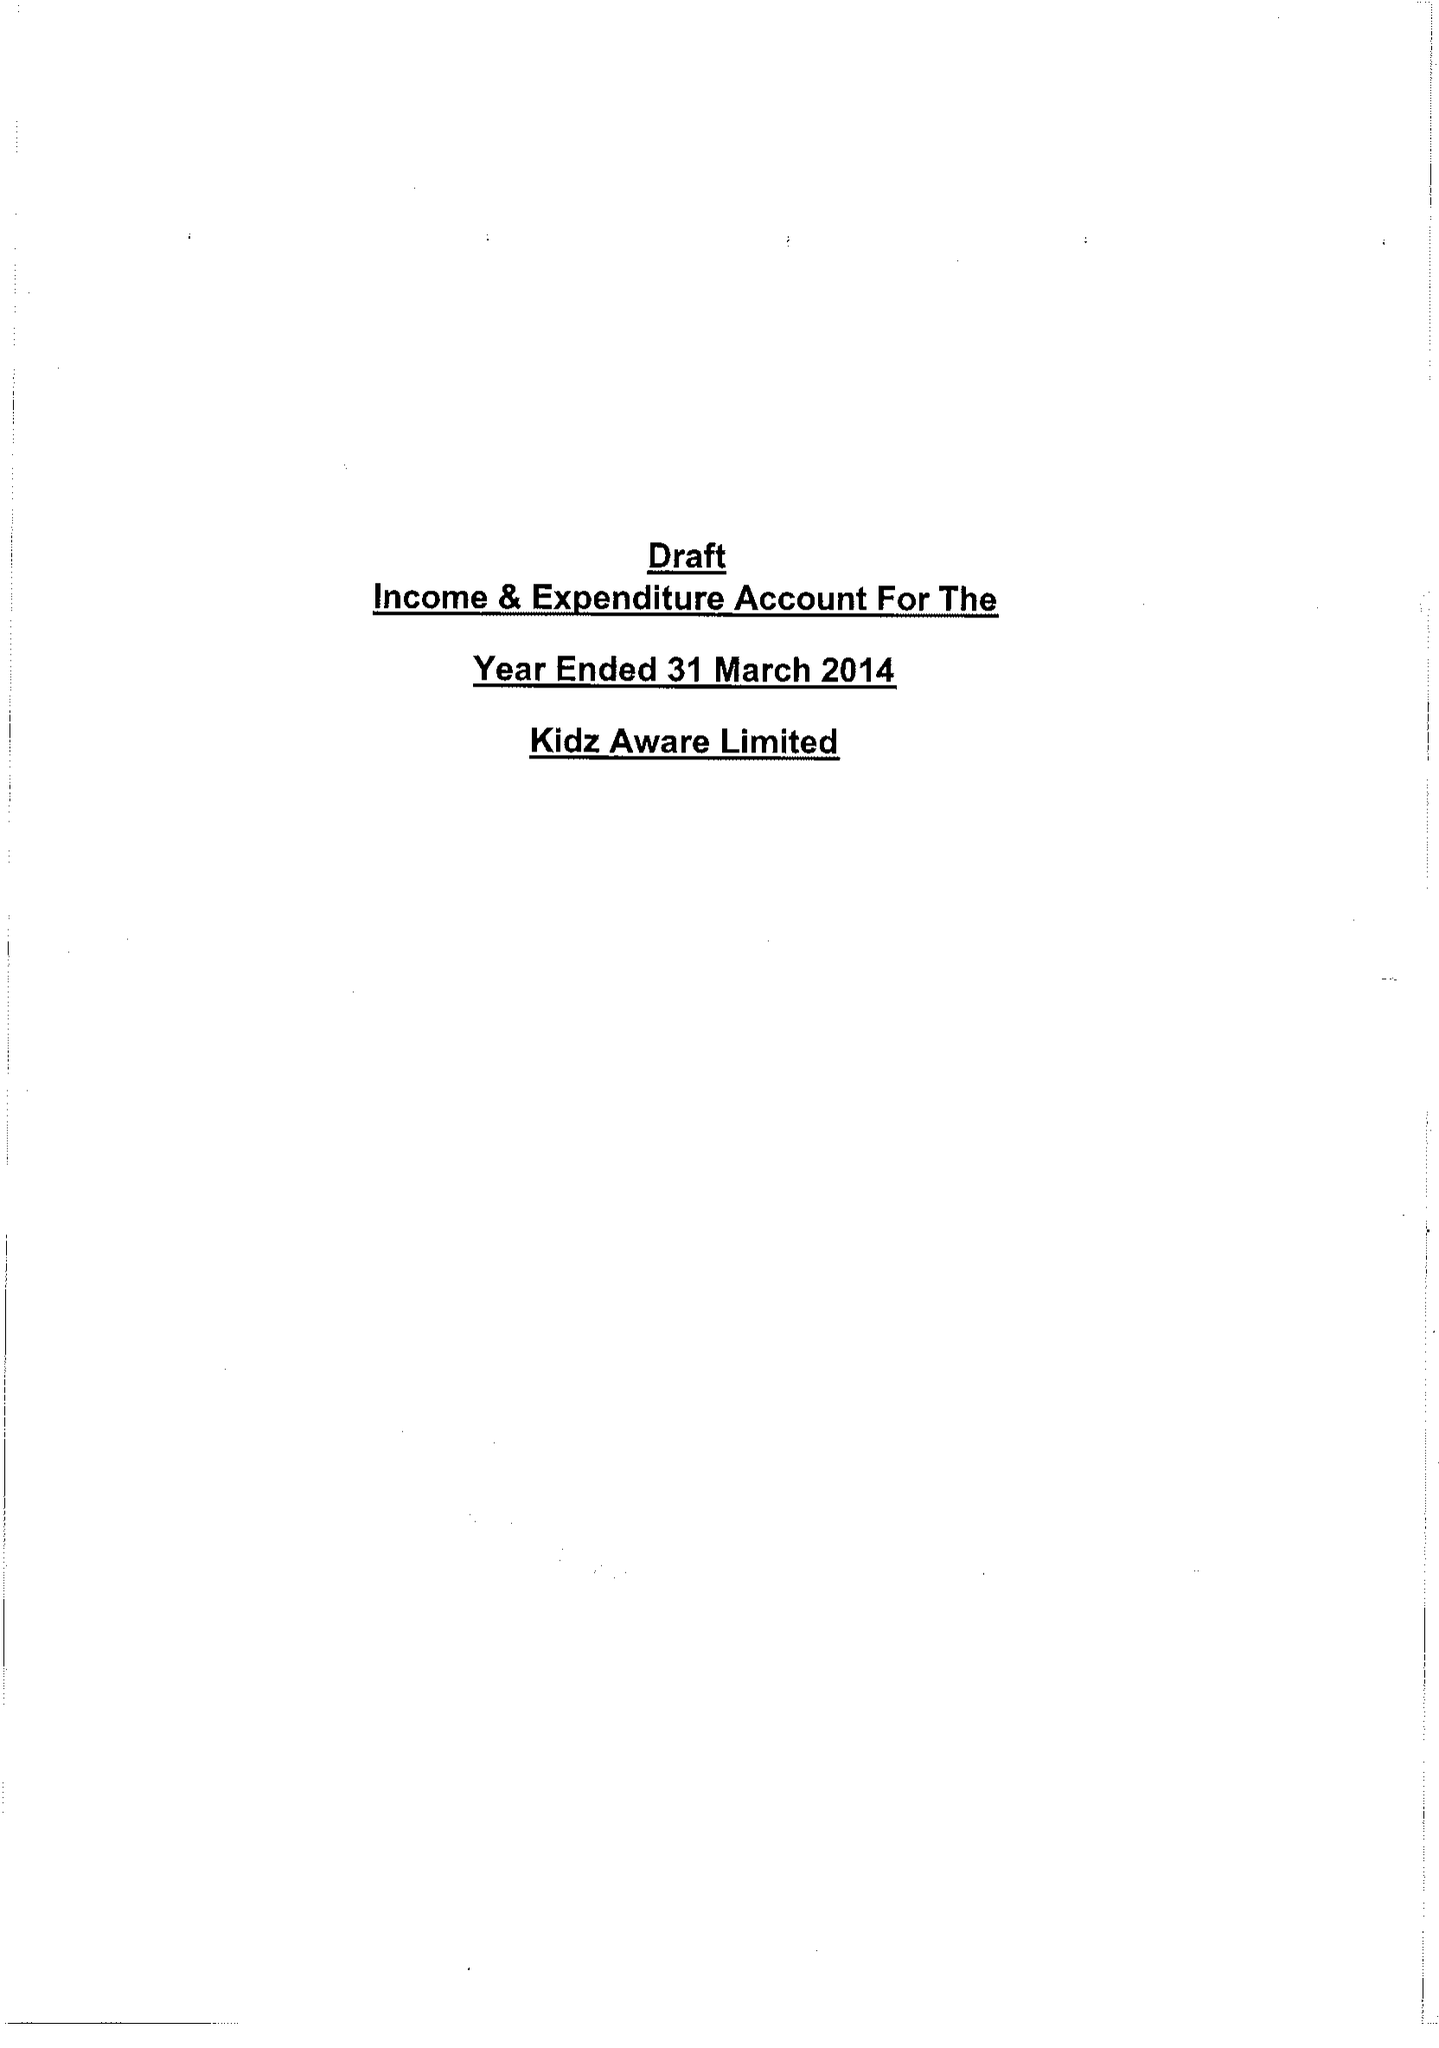What is the value for the address__post_town?
Answer the question using a single word or phrase. WAKEFIELD 